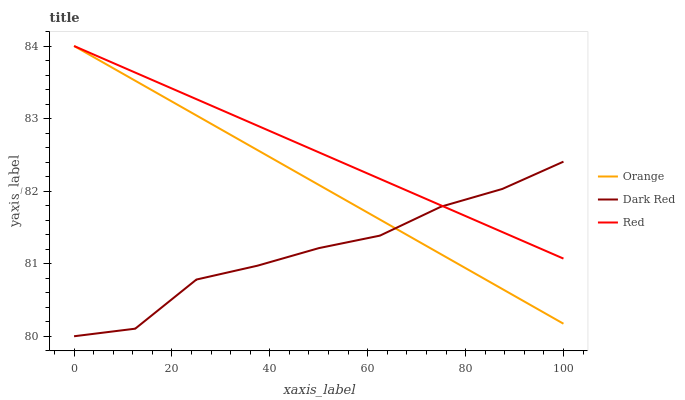Does Dark Red have the minimum area under the curve?
Answer yes or no. Yes. Does Red have the maximum area under the curve?
Answer yes or no. Yes. Does Red have the minimum area under the curve?
Answer yes or no. No. Does Dark Red have the maximum area under the curve?
Answer yes or no. No. Is Orange the smoothest?
Answer yes or no. Yes. Is Dark Red the roughest?
Answer yes or no. Yes. Is Red the smoothest?
Answer yes or no. No. Is Red the roughest?
Answer yes or no. No. Does Dark Red have the lowest value?
Answer yes or no. Yes. Does Red have the lowest value?
Answer yes or no. No. Does Red have the highest value?
Answer yes or no. Yes. Does Dark Red have the highest value?
Answer yes or no. No. Does Orange intersect Red?
Answer yes or no. Yes. Is Orange less than Red?
Answer yes or no. No. Is Orange greater than Red?
Answer yes or no. No. 